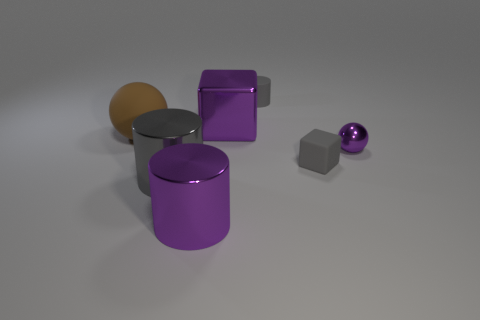What are the differences in textures that you can see in the objects? The reflected light on the objects indicates a variety of textures. The purple cube and cylinder seem to have a matte surface, which diffuses light softly. In contrast, the small sphere and the side of the orange-tinted cylinder have a glossy finish that reflects light sharply, suggesting a smoother, perhaps metallic, texture. The gray cube appears to have a slightly rougher surface than the other objects, possibly resembling concrete or stone. 